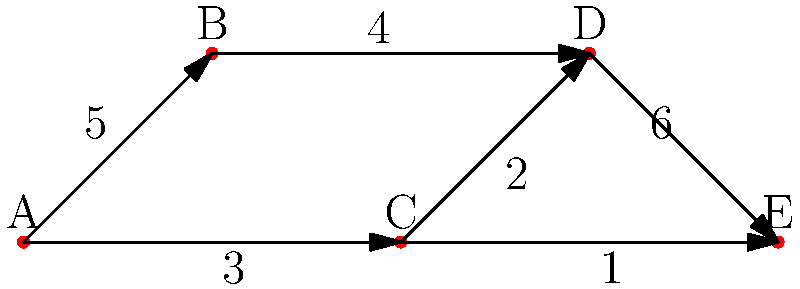In your sustainable fashion brand's social media network, each node represents a platform (A: Instagram, B: Facebook, C: Twitter, D: Pinterest, E: TikTok), and directed edges represent the flow of followers from one platform to another. Edge weights indicate the number of followers (in thousands) that typically follow your brand from one platform to another when promoted. What is the maximum number of followers (in thousands) that can be directed from Instagram (A) to TikTok (E) using this network? To find the maximum number of followers that can be directed from Instagram (A) to TikTok (E), we need to find the path with the maximum flow from A to E. This is equivalent to finding the path with the maximum capacity in a flow network.

Let's analyze all possible paths from A to E:

1. A → B → D → E: min(5, 4, 6) = 4
2. A → C → D → E: min(3, 2, 6) = 2
3. A → C → E: min(3, 1) = 1

The maximum flow is determined by the path with the highest minimum capacity. In this case, it's path 1: A → B → D → E, with a capacity of 4.

Therefore, the maximum number of followers (in thousands) that can be directed from Instagram (A) to TikTok (E) is 4,000.
Answer: 4 thousand followers 